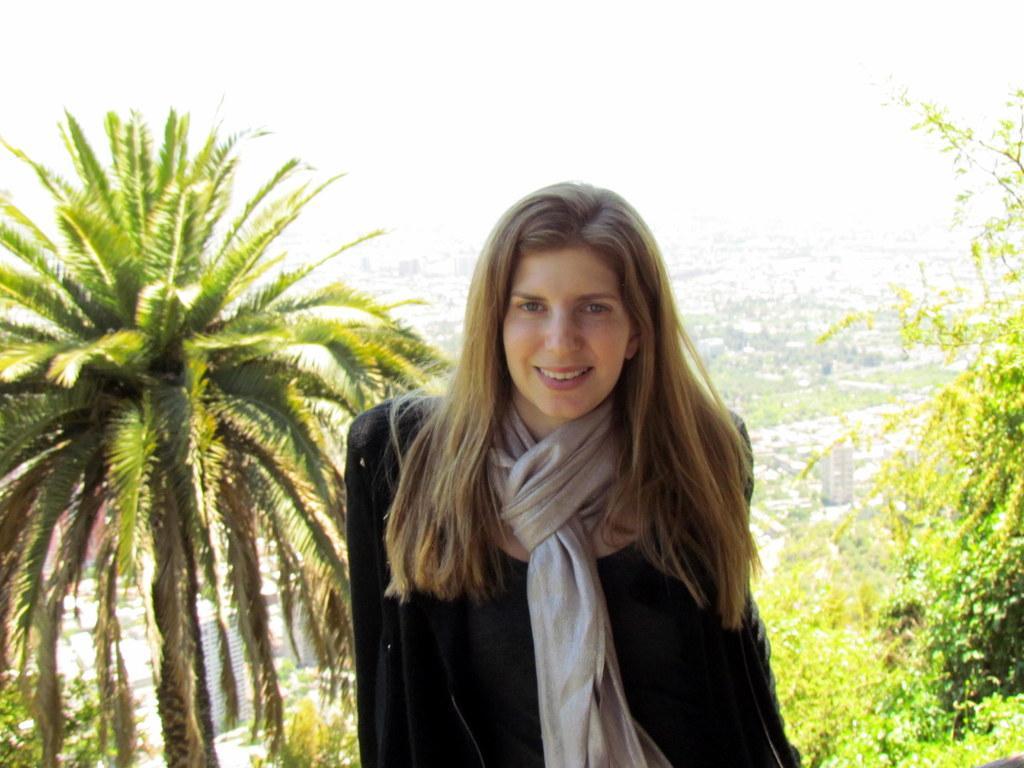In one or two sentences, can you explain what this image depicts? In this image I can see a woman wearing a black color suit, neckwear, smiling and giving pose for the picture. In the background, I can see the trees and buildings. 